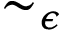<formula> <loc_0><loc_0><loc_500><loc_500>\sim _ { \epsilon }</formula> 